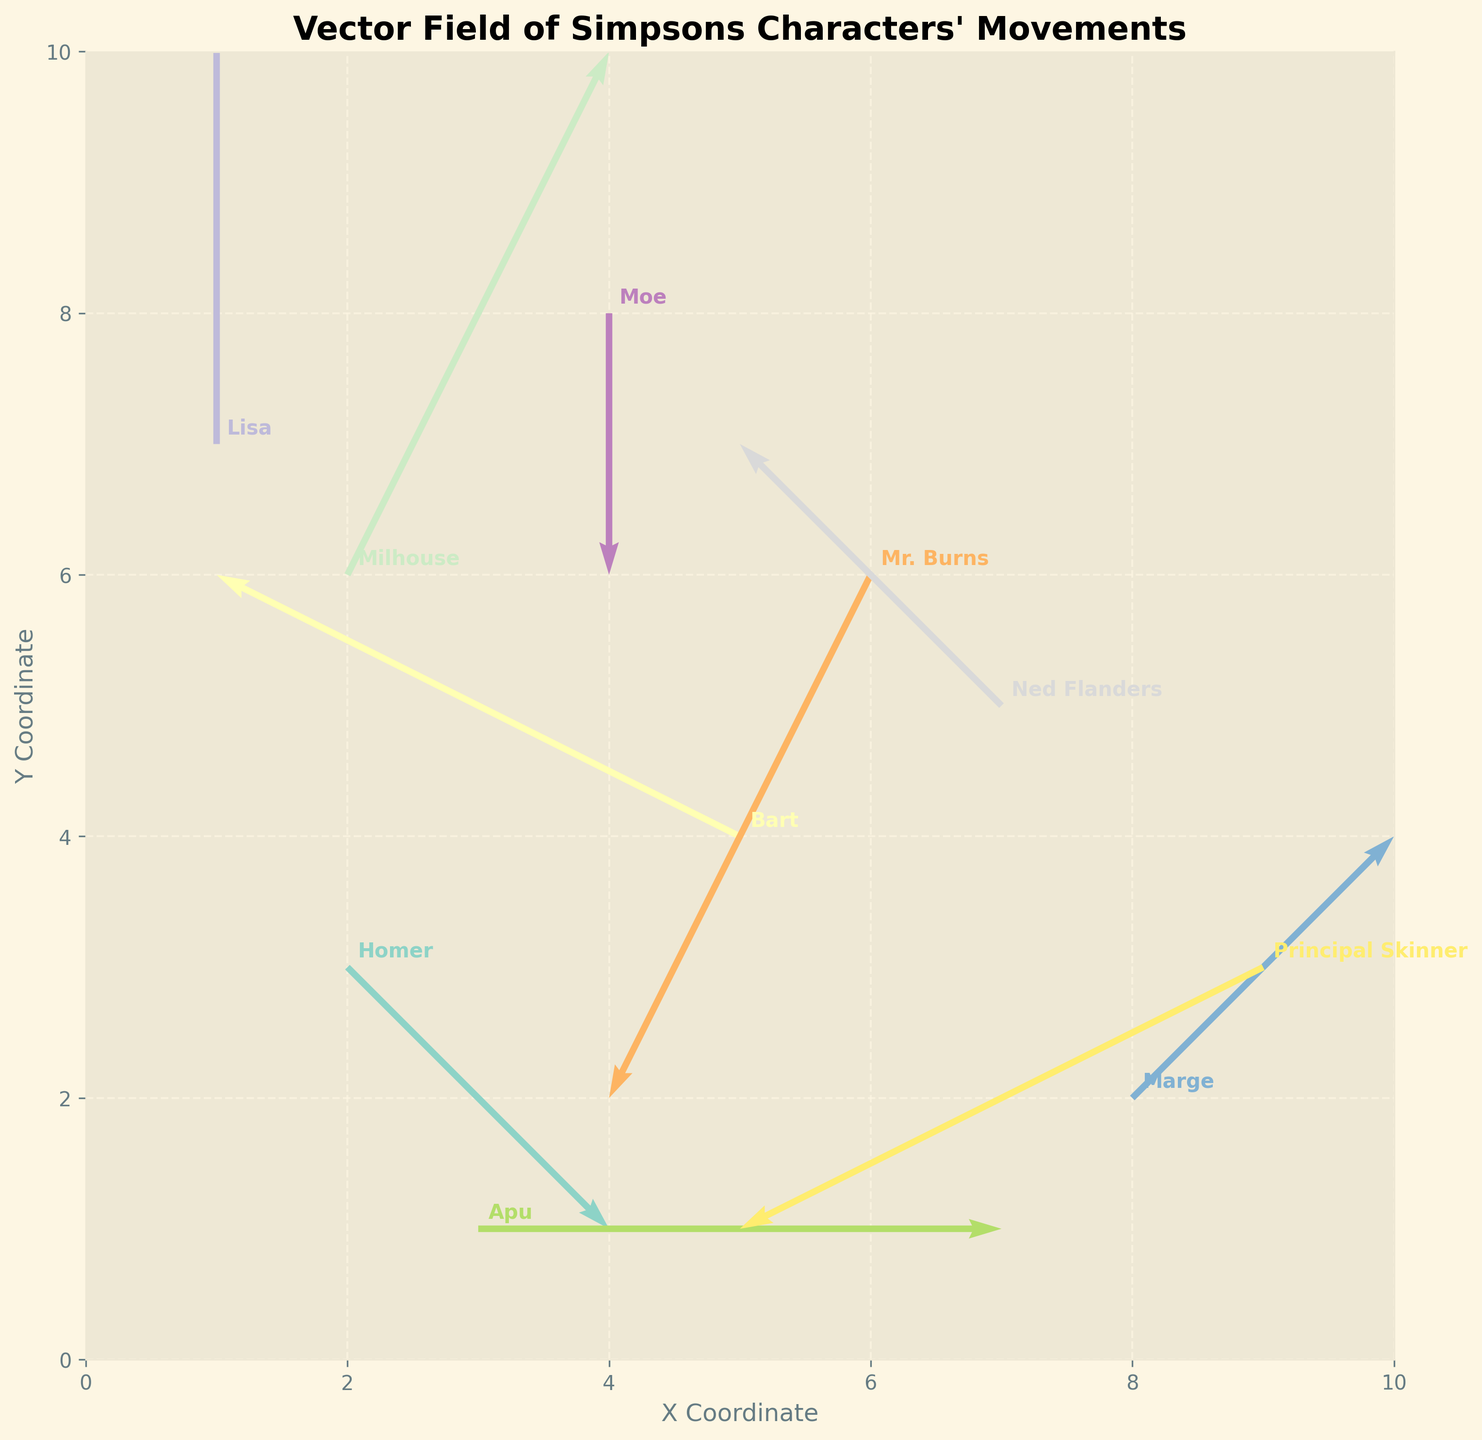What's the title of the plot? The title of the plot is displayed at the top of the figure in bold font. Reading the title shows: "Vector Field of Simpsons Characters' Movements".
Answer: Vector Field of Simpsons Characters' Movements How many characters' movements are represented in the plot? By counting the number of arrows or labels annotated near the arrows, we can determine the number of characters, which is 10.
Answer: 10 Who has the longest movement vector? By examining the length of the arrows on the plot, we find that Milhouse, with vector (1, 2), has the longest arrow.
Answer: Milhouse Which character moves directly upwards? The character whose arrow points directly upwards has a vertical vector component and no horizontal component. This is Lisa, with a movement vector (0, 2).
Answer: Lisa Between Homer and Mr. Burns, who has a downward movement direction? We need to look at the vertical component (v) of their vectors. Homer has (1, -1) and Mr. Burns has (-1, -2). Both vectors have a negative vertical component but Mr. Burns’ vertical movement is more significant.
Answer: Mr. Burns What's the difference in the x-coordinates of Marge and Principal Skinner? The x-coordinate of Marge is 8 and that of Principal Skinner is 9. The difference in their x-coordinates is 9 - 8.
Answer: 1 Which characters are moving towards the left? Characters moving towards the left have a negative value for the horizontal component (u). These are Bart (-2, 1), Mr. Burns (-1, -2), Ned Flanders (-1, 1), and Principal Skinner (-2, -1).
Answer: Bart, Mr. Burns, Ned Flanders, Principal Skinner What is the average y-coordinate of Homer and Bart? Homer’s y-coordinate is 3 and Bart's is 4. The average of these coordinates is (3 + 4) / 2.
Answer: 3.5 Which character has no horizontal movement? The character with u = 0 has no horizontal movement. This is Lisa with vector (0, 2) and Moe with vector (0, -1).
Answer: Lisa, Moe Considering both x and y components, which character has the smallest net movement? Net movement can be calculated using the Pythagorean theorem: √(u^2 + v^2). Calculating for each and comparing, Principal Skinner with vector (-2, -1) results in √(2^2 + 1^2) = √5, Ned Flanders with (-1, 1) results in √(1 + 1) = √2, etc. Smaller overall value is for Ned Flanders with √2.
Answer: Ned Flanders 